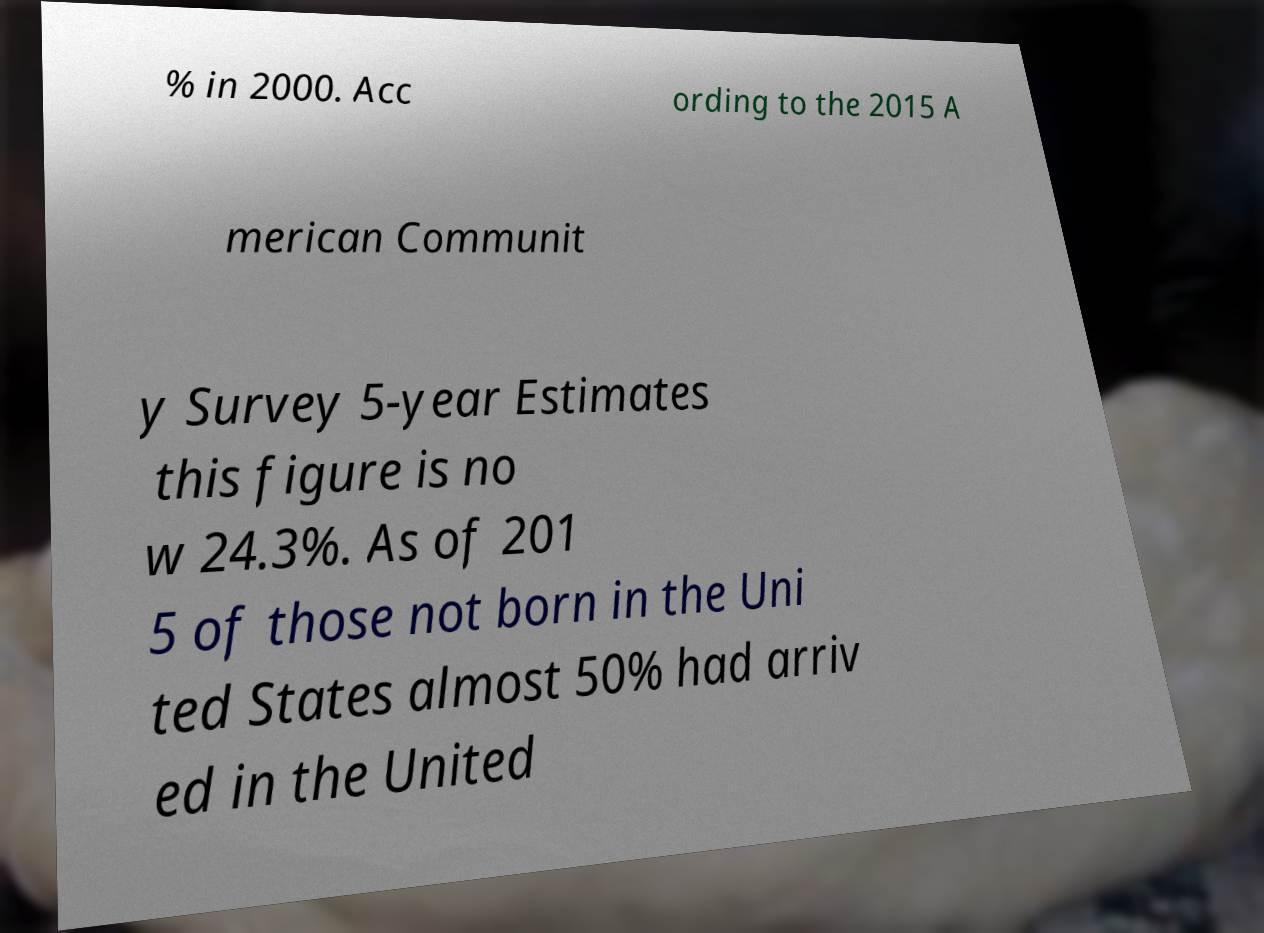There's text embedded in this image that I need extracted. Can you transcribe it verbatim? % in 2000. Acc ording to the 2015 A merican Communit y Survey 5-year Estimates this figure is no w 24.3%. As of 201 5 of those not born in the Uni ted States almost 50% had arriv ed in the United 